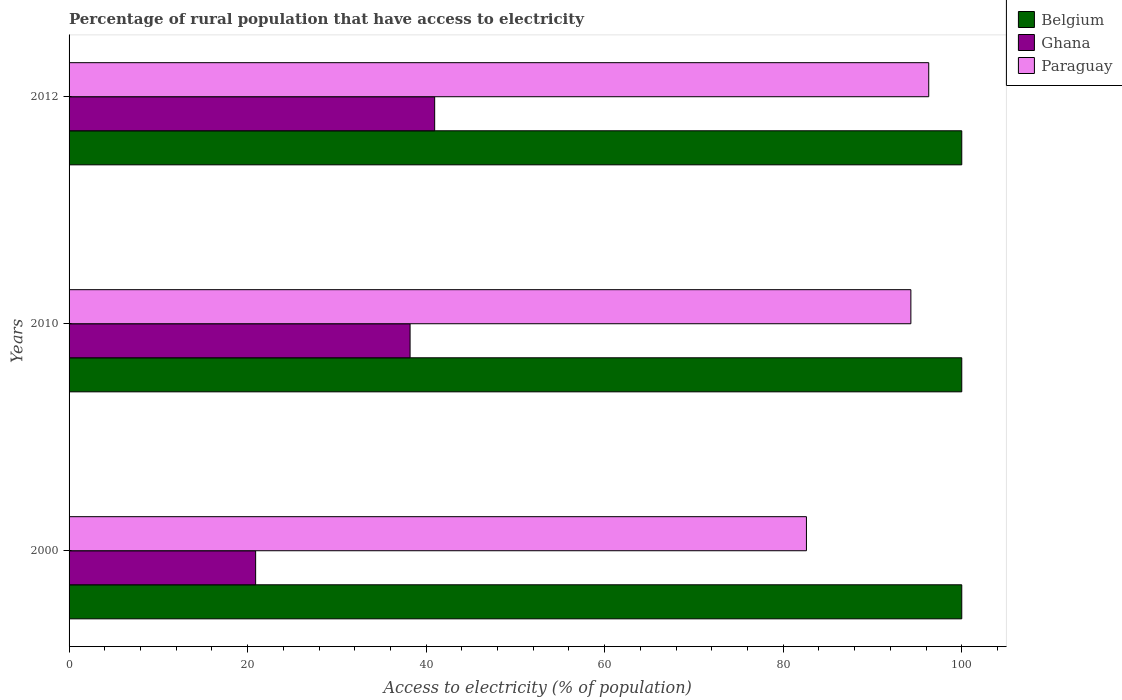Are the number of bars per tick equal to the number of legend labels?
Keep it short and to the point. Yes. What is the label of the 1st group of bars from the top?
Offer a very short reply. 2012. What is the percentage of rural population that have access to electricity in Ghana in 2010?
Offer a terse response. 38.2. Across all years, what is the maximum percentage of rural population that have access to electricity in Belgium?
Your answer should be compact. 100. Across all years, what is the minimum percentage of rural population that have access to electricity in Paraguay?
Your response must be concise. 82.6. In which year was the percentage of rural population that have access to electricity in Ghana maximum?
Your answer should be very brief. 2012. In which year was the percentage of rural population that have access to electricity in Paraguay minimum?
Offer a very short reply. 2000. What is the total percentage of rural population that have access to electricity in Ghana in the graph?
Give a very brief answer. 100.05. What is the difference between the percentage of rural population that have access to electricity in Belgium in 2000 and that in 2010?
Make the answer very short. 0. What is the difference between the percentage of rural population that have access to electricity in Ghana in 2010 and the percentage of rural population that have access to electricity in Paraguay in 2012?
Offer a very short reply. -58.1. What is the average percentage of rural population that have access to electricity in Belgium per year?
Ensure brevity in your answer.  100. In the year 2000, what is the difference between the percentage of rural population that have access to electricity in Belgium and percentage of rural population that have access to electricity in Ghana?
Your answer should be compact. 79.1. In how many years, is the percentage of rural population that have access to electricity in Belgium greater than 60 %?
Offer a terse response. 3. What is the ratio of the percentage of rural population that have access to electricity in Belgium in 2000 to that in 2010?
Make the answer very short. 1. Is the percentage of rural population that have access to electricity in Belgium in 2000 less than that in 2010?
Ensure brevity in your answer.  No. Is the difference between the percentage of rural population that have access to electricity in Belgium in 2000 and 2012 greater than the difference between the percentage of rural population that have access to electricity in Ghana in 2000 and 2012?
Your answer should be compact. Yes. Is the sum of the percentage of rural population that have access to electricity in Ghana in 2000 and 2010 greater than the maximum percentage of rural population that have access to electricity in Belgium across all years?
Your response must be concise. No. What does the 1st bar from the top in 2010 represents?
Provide a succinct answer. Paraguay. What does the 2nd bar from the bottom in 2010 represents?
Offer a terse response. Ghana. How many bars are there?
Keep it short and to the point. 9. Are all the bars in the graph horizontal?
Your answer should be very brief. Yes. How many years are there in the graph?
Provide a succinct answer. 3. What is the difference between two consecutive major ticks on the X-axis?
Keep it short and to the point. 20. Are the values on the major ticks of X-axis written in scientific E-notation?
Give a very brief answer. No. Does the graph contain any zero values?
Ensure brevity in your answer.  No. Does the graph contain grids?
Make the answer very short. No. Where does the legend appear in the graph?
Make the answer very short. Top right. How many legend labels are there?
Make the answer very short. 3. How are the legend labels stacked?
Your answer should be compact. Vertical. What is the title of the graph?
Your response must be concise. Percentage of rural population that have access to electricity. What is the label or title of the X-axis?
Your answer should be very brief. Access to electricity (% of population). What is the Access to electricity (% of population) of Ghana in 2000?
Provide a short and direct response. 20.9. What is the Access to electricity (% of population) of Paraguay in 2000?
Offer a very short reply. 82.6. What is the Access to electricity (% of population) of Ghana in 2010?
Make the answer very short. 38.2. What is the Access to electricity (% of population) of Paraguay in 2010?
Your response must be concise. 94.3. What is the Access to electricity (% of population) in Belgium in 2012?
Keep it short and to the point. 100. What is the Access to electricity (% of population) of Ghana in 2012?
Your answer should be compact. 40.95. What is the Access to electricity (% of population) in Paraguay in 2012?
Offer a very short reply. 96.3. Across all years, what is the maximum Access to electricity (% of population) in Ghana?
Provide a succinct answer. 40.95. Across all years, what is the maximum Access to electricity (% of population) in Paraguay?
Keep it short and to the point. 96.3. Across all years, what is the minimum Access to electricity (% of population) of Ghana?
Keep it short and to the point. 20.9. Across all years, what is the minimum Access to electricity (% of population) of Paraguay?
Your answer should be compact. 82.6. What is the total Access to electricity (% of population) in Belgium in the graph?
Offer a terse response. 300. What is the total Access to electricity (% of population) of Ghana in the graph?
Provide a short and direct response. 100.05. What is the total Access to electricity (% of population) in Paraguay in the graph?
Your answer should be very brief. 273.2. What is the difference between the Access to electricity (% of population) of Ghana in 2000 and that in 2010?
Your answer should be very brief. -17.3. What is the difference between the Access to electricity (% of population) of Paraguay in 2000 and that in 2010?
Offer a terse response. -11.7. What is the difference between the Access to electricity (% of population) in Belgium in 2000 and that in 2012?
Your answer should be compact. 0. What is the difference between the Access to electricity (% of population) of Ghana in 2000 and that in 2012?
Your response must be concise. -20.05. What is the difference between the Access to electricity (% of population) of Paraguay in 2000 and that in 2012?
Offer a very short reply. -13.7. What is the difference between the Access to electricity (% of population) of Belgium in 2010 and that in 2012?
Your answer should be compact. 0. What is the difference between the Access to electricity (% of population) in Ghana in 2010 and that in 2012?
Offer a terse response. -2.75. What is the difference between the Access to electricity (% of population) of Belgium in 2000 and the Access to electricity (% of population) of Ghana in 2010?
Make the answer very short. 61.8. What is the difference between the Access to electricity (% of population) in Ghana in 2000 and the Access to electricity (% of population) in Paraguay in 2010?
Your response must be concise. -73.4. What is the difference between the Access to electricity (% of population) in Belgium in 2000 and the Access to electricity (% of population) in Ghana in 2012?
Keep it short and to the point. 59.05. What is the difference between the Access to electricity (% of population) in Belgium in 2000 and the Access to electricity (% of population) in Paraguay in 2012?
Give a very brief answer. 3.7. What is the difference between the Access to electricity (% of population) of Ghana in 2000 and the Access to electricity (% of population) of Paraguay in 2012?
Keep it short and to the point. -75.4. What is the difference between the Access to electricity (% of population) in Belgium in 2010 and the Access to electricity (% of population) in Ghana in 2012?
Your answer should be compact. 59.05. What is the difference between the Access to electricity (% of population) in Belgium in 2010 and the Access to electricity (% of population) in Paraguay in 2012?
Your answer should be compact. 3.7. What is the difference between the Access to electricity (% of population) of Ghana in 2010 and the Access to electricity (% of population) of Paraguay in 2012?
Offer a very short reply. -58.1. What is the average Access to electricity (% of population) in Ghana per year?
Provide a short and direct response. 33.35. What is the average Access to electricity (% of population) in Paraguay per year?
Keep it short and to the point. 91.07. In the year 2000, what is the difference between the Access to electricity (% of population) of Belgium and Access to electricity (% of population) of Ghana?
Provide a short and direct response. 79.1. In the year 2000, what is the difference between the Access to electricity (% of population) of Ghana and Access to electricity (% of population) of Paraguay?
Make the answer very short. -61.7. In the year 2010, what is the difference between the Access to electricity (% of population) in Belgium and Access to electricity (% of population) in Ghana?
Your answer should be compact. 61.8. In the year 2010, what is the difference between the Access to electricity (% of population) in Ghana and Access to electricity (% of population) in Paraguay?
Make the answer very short. -56.1. In the year 2012, what is the difference between the Access to electricity (% of population) of Belgium and Access to electricity (% of population) of Ghana?
Your response must be concise. 59.05. In the year 2012, what is the difference between the Access to electricity (% of population) in Belgium and Access to electricity (% of population) in Paraguay?
Offer a very short reply. 3.7. In the year 2012, what is the difference between the Access to electricity (% of population) of Ghana and Access to electricity (% of population) of Paraguay?
Your answer should be very brief. -55.35. What is the ratio of the Access to electricity (% of population) in Belgium in 2000 to that in 2010?
Provide a short and direct response. 1. What is the ratio of the Access to electricity (% of population) in Ghana in 2000 to that in 2010?
Provide a succinct answer. 0.55. What is the ratio of the Access to electricity (% of population) of Paraguay in 2000 to that in 2010?
Offer a very short reply. 0.88. What is the ratio of the Access to electricity (% of population) of Belgium in 2000 to that in 2012?
Make the answer very short. 1. What is the ratio of the Access to electricity (% of population) in Ghana in 2000 to that in 2012?
Your response must be concise. 0.51. What is the ratio of the Access to electricity (% of population) of Paraguay in 2000 to that in 2012?
Make the answer very short. 0.86. What is the ratio of the Access to electricity (% of population) in Ghana in 2010 to that in 2012?
Provide a succinct answer. 0.93. What is the ratio of the Access to electricity (% of population) of Paraguay in 2010 to that in 2012?
Your answer should be compact. 0.98. What is the difference between the highest and the second highest Access to electricity (% of population) in Belgium?
Your answer should be compact. 0. What is the difference between the highest and the second highest Access to electricity (% of population) in Ghana?
Make the answer very short. 2.75. What is the difference between the highest and the second highest Access to electricity (% of population) in Paraguay?
Keep it short and to the point. 2. What is the difference between the highest and the lowest Access to electricity (% of population) of Belgium?
Make the answer very short. 0. What is the difference between the highest and the lowest Access to electricity (% of population) of Ghana?
Your answer should be very brief. 20.05. 